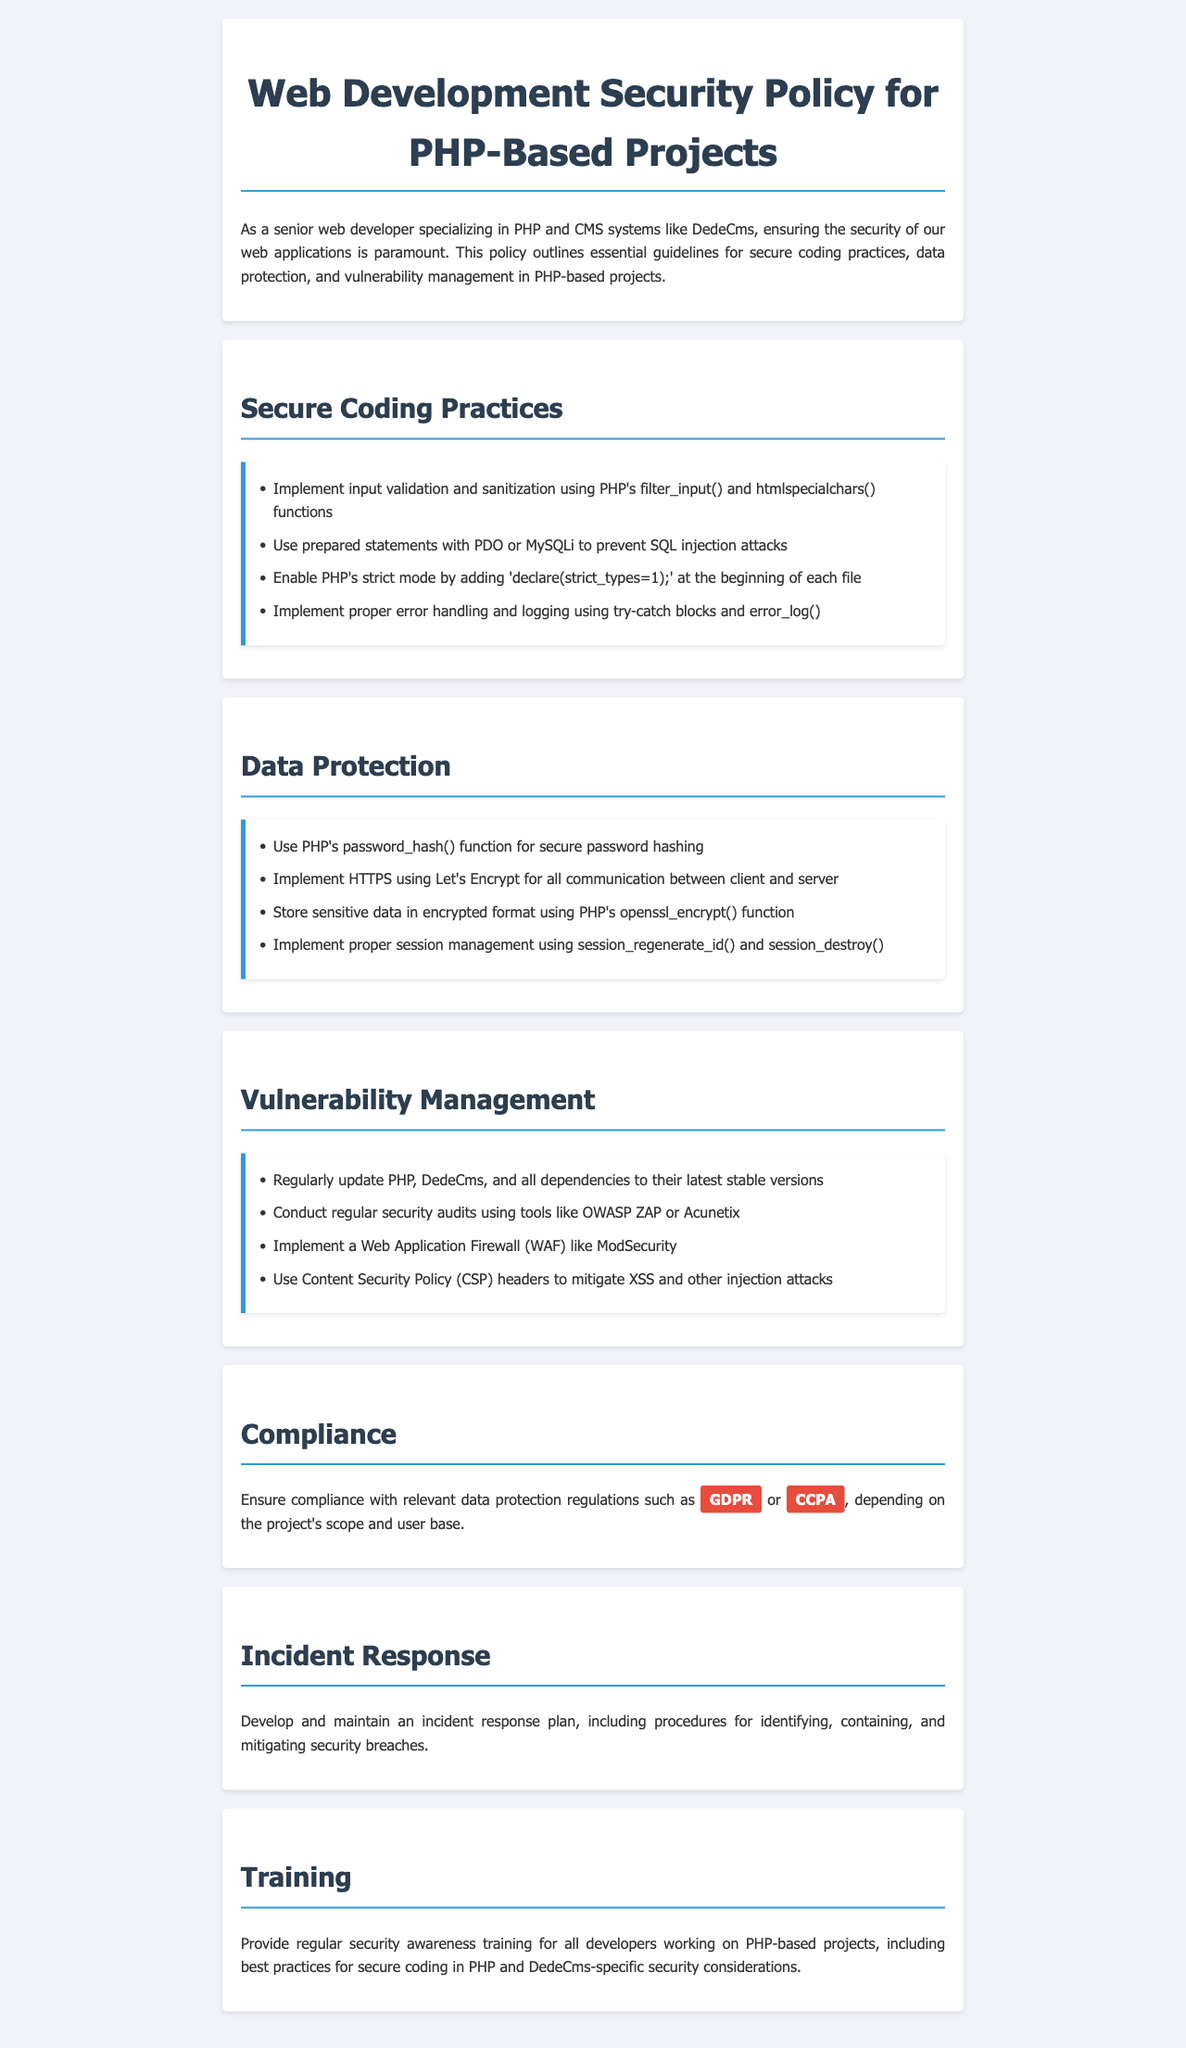What is the title of the document? The title of the document is stated in the HTML head section, indicating the focus of the policy.
Answer: Web Development Security Policy for PHP-Based Projects What feature prevents SQL injection? This refers to a specific coding practice mentioned in the document that enhances security against SQL injection attacks.
Answer: Prepared statements Which function is recommended for secure password hashing? The document highlights a particular PHP function essential for secure password management.
Answer: password_hash() What is implemented for all communication between client and server? This specifies a security mechanism emphasized in the data protection section of the document.
Answer: HTTPS Which tool can be used for regular security audits? The document lists a specific tool to help assess security regularly, enhancing overall security strategy.
Answer: OWASP ZAP What are developers encouraged to provide regularly? This emphasizes the importance of continual learning and security awareness among developers identified in the training section.
Answer: Security awareness training What security measure can mitigate XSS attacks? Referring to a specific strategy mentioned in the vulnerability management section aimed at preventing cross-site scripting attacks.
Answer: Content Security Policy Which data protection regulation is highlighted? The document explicitly refers to a significant legal framework governing data protection relevant to the projects.
Answer: GDPR What should be maintained for security breaches? The document stresses creating a specific plan to address security incidents effectively.
Answer: Incident response plan 